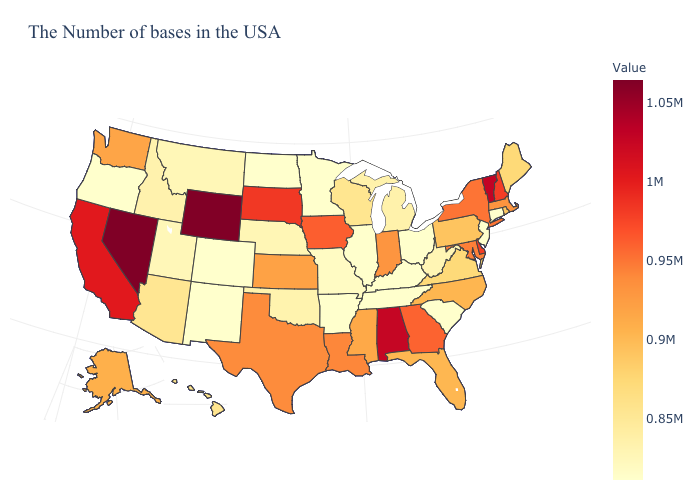Is the legend a continuous bar?
Give a very brief answer. Yes. Does Alaska have a lower value than Oklahoma?
Short answer required. No. Among the states that border Arizona , does Colorado have the lowest value?
Keep it brief. Yes. Does Colorado have a higher value than Wisconsin?
Concise answer only. No. Among the states that border New York , which have the highest value?
Keep it brief. Vermont. 